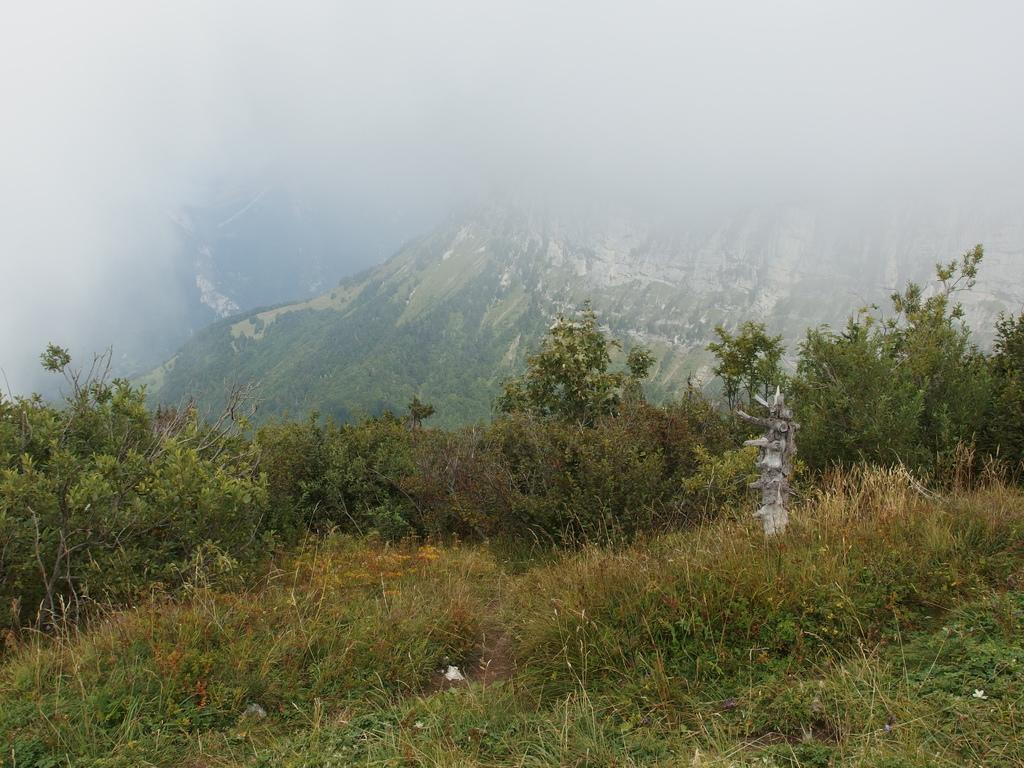What type of natural elements can be seen in the image? There are trees and mountains in the image. Can you describe the landscape in the image? The image features a landscape with trees and mountains. What type of grape is hanging from the trees in the image? There are no grapes present in the image; it features trees and mountains. 